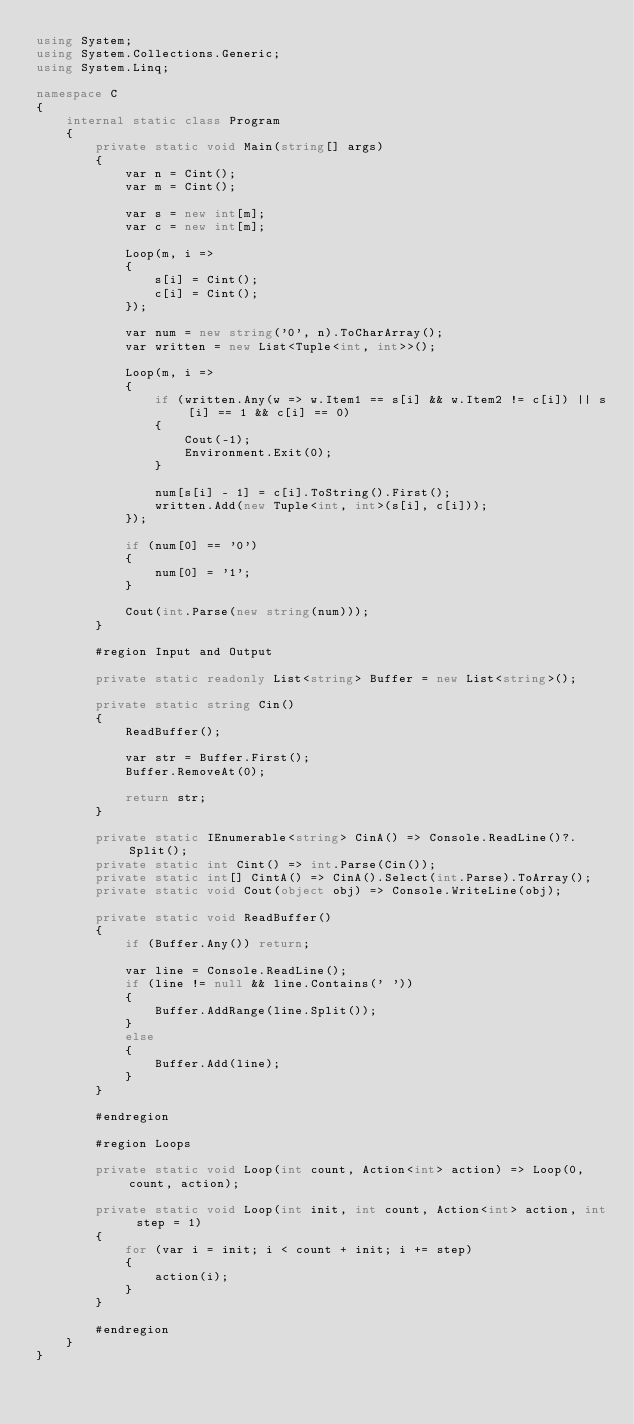<code> <loc_0><loc_0><loc_500><loc_500><_C#_>using System;
using System.Collections.Generic;
using System.Linq;

namespace C
{
    internal static class Program
    {
        private static void Main(string[] args)
        {
            var n = Cint();
            var m = Cint();

            var s = new int[m];
            var c = new int[m];

            Loop(m, i =>
            {
                s[i] = Cint();
                c[i] = Cint();
            });

            var num = new string('0', n).ToCharArray();
            var written = new List<Tuple<int, int>>();

            Loop(m, i =>
            {
                if (written.Any(w => w.Item1 == s[i] && w.Item2 != c[i]) || s[i] == 1 && c[i] == 0)
                {
                    Cout(-1);
                    Environment.Exit(0);
                }
                
                num[s[i] - 1] = c[i].ToString().First();
                written.Add(new Tuple<int, int>(s[i], c[i]));
            });

            if (num[0] == '0')
            {
                num[0] = '1';
            }
            
            Cout(int.Parse(new string(num)));
        }

        #region Input and Output

        private static readonly List<string> Buffer = new List<string>();

        private static string Cin()
        {
            ReadBuffer();

            var str = Buffer.First();
            Buffer.RemoveAt(0);

            return str;
        }

        private static IEnumerable<string> CinA() => Console.ReadLine()?.Split();
        private static int Cint() => int.Parse(Cin());
        private static int[] CintA() => CinA().Select(int.Parse).ToArray();
        private static void Cout(object obj) => Console.WriteLine(obj);

        private static void ReadBuffer()
        {
            if (Buffer.Any()) return;

            var line = Console.ReadLine();
            if (line != null && line.Contains(' '))
            {
                Buffer.AddRange(line.Split());
            }
            else
            {
                Buffer.Add(line);
            }
        }

        #endregion

        #region Loops

        private static void Loop(int count, Action<int> action) => Loop(0, count, action);

        private static void Loop(int init, int count, Action<int> action, int step = 1)
        {
            for (var i = init; i < count + init; i += step)
            {
                action(i);
            }
        }

        #endregion
    }
}
</code> 